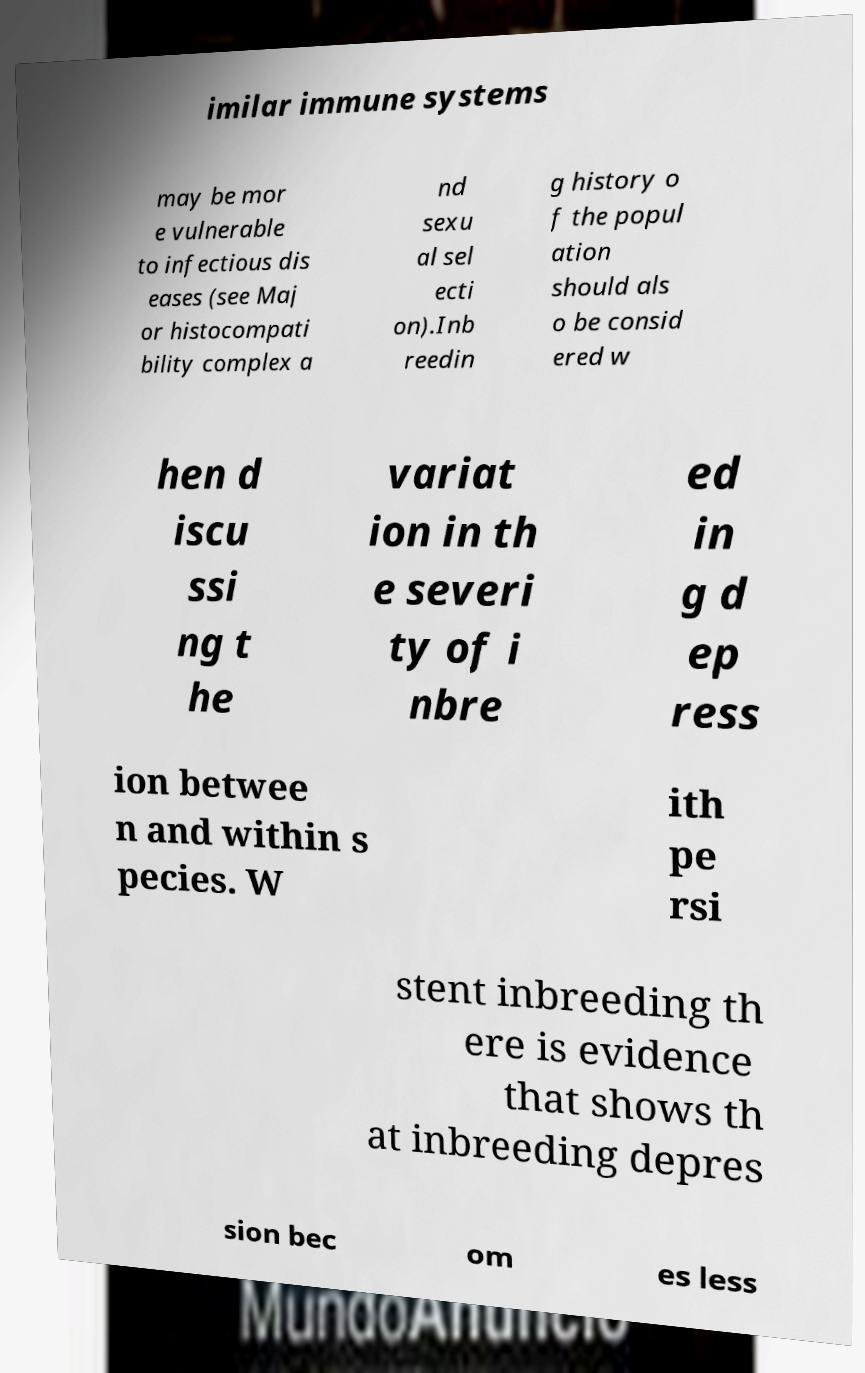For documentation purposes, I need the text within this image transcribed. Could you provide that? imilar immune systems may be mor e vulnerable to infectious dis eases (see Maj or histocompati bility complex a nd sexu al sel ecti on).Inb reedin g history o f the popul ation should als o be consid ered w hen d iscu ssi ng t he variat ion in th e severi ty of i nbre ed in g d ep ress ion betwee n and within s pecies. W ith pe rsi stent inbreeding th ere is evidence that shows th at inbreeding depres sion bec om es less 